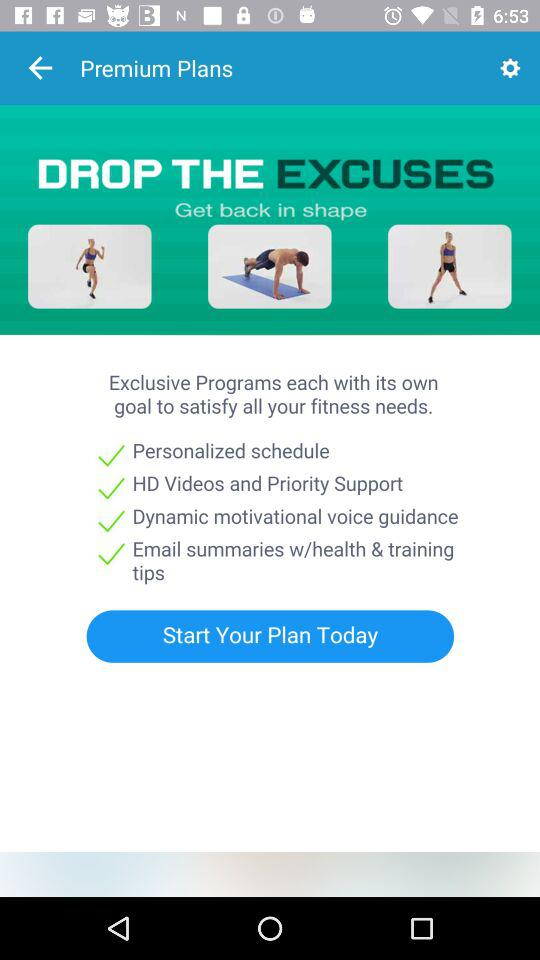What is the plan today?
When the provided information is insufficient, respond with <no answer>. <no answer> 